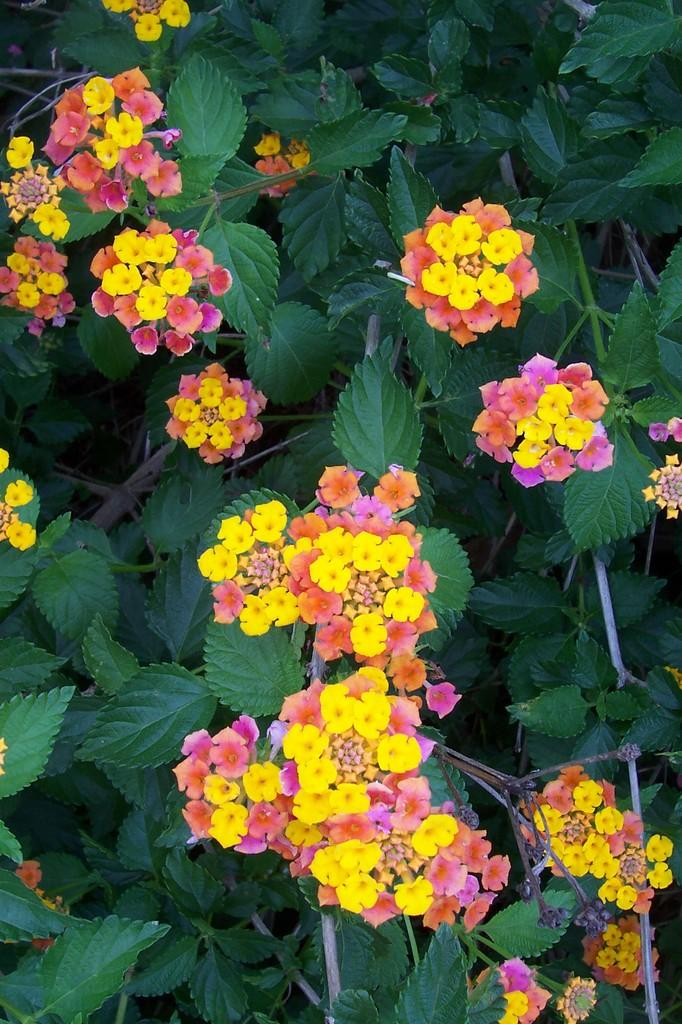What type of living organisms are in the image? The image contains plants. What specific parts of the plants are visible in the image? The plants have leaves and flowers. What type of trick can be seen being performed with a rake in the image? There is no rake or trick present in the image; it features plants with leaves and flowers. 